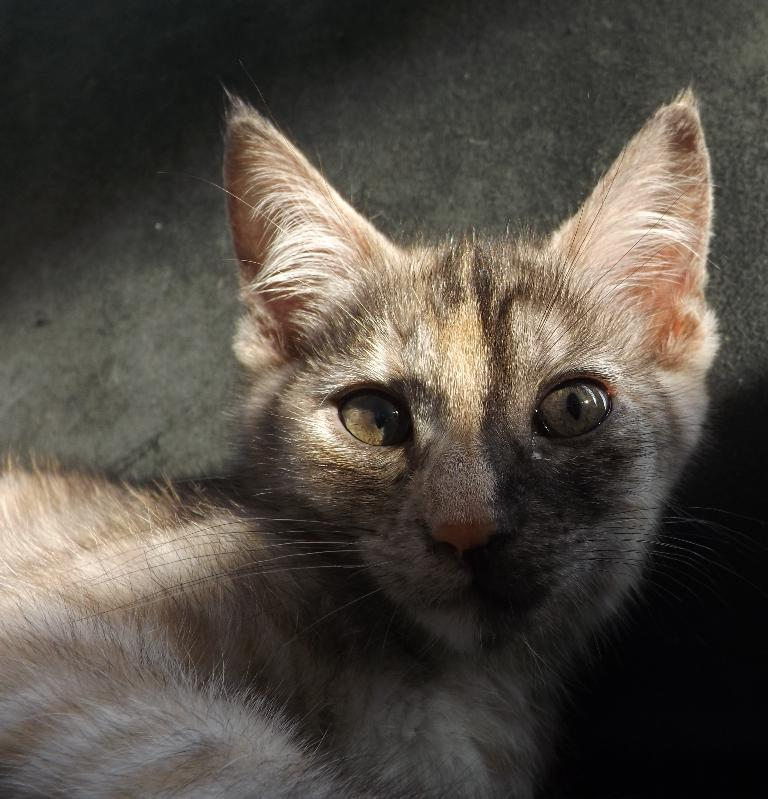What type of animal is in the image? There is a cat in the image. Can you describe the coloring of the cat? The cat has brown and cream coloring. What type of berry is the cat holding in the image? There is no berry present in the image, and the cat is not holding anything. 